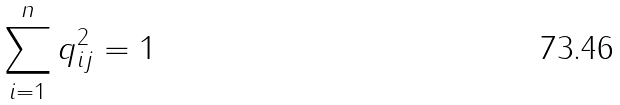Convert formula to latex. <formula><loc_0><loc_0><loc_500><loc_500>\sum _ { i = 1 } ^ { n } q _ { i j } ^ { 2 } = 1</formula> 